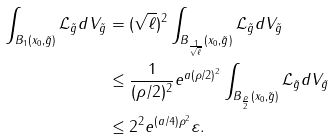Convert formula to latex. <formula><loc_0><loc_0><loc_500><loc_500>\int _ { B _ { 1 } ( x _ { 0 } , \tilde { g } ) } \mathcal { L } _ { \tilde { g } } d V _ { \tilde { g } } & = ( \sqrt { \ell } ) ^ { 2 } \int _ { B _ { \frac { 1 } { \sqrt { \ell } } } ( x _ { 0 } , \tilde { g } ) } \mathcal { L } _ { \tilde { g } } d V _ { \tilde { g } } \\ & \leq \frac { 1 } { ( \rho / 2 ) ^ { 2 } } e ^ { a ( \rho / 2 ) ^ { 2 } } \int _ { B _ { \frac { \rho } { 2 } } ( x _ { 0 } , \tilde { g } ) } \mathcal { L } _ { \tilde { g } } d V _ { \tilde { g } } \\ & \leq 2 ^ { 2 } e ^ { ( a / 4 ) \rho ^ { 2 } } \varepsilon .</formula> 